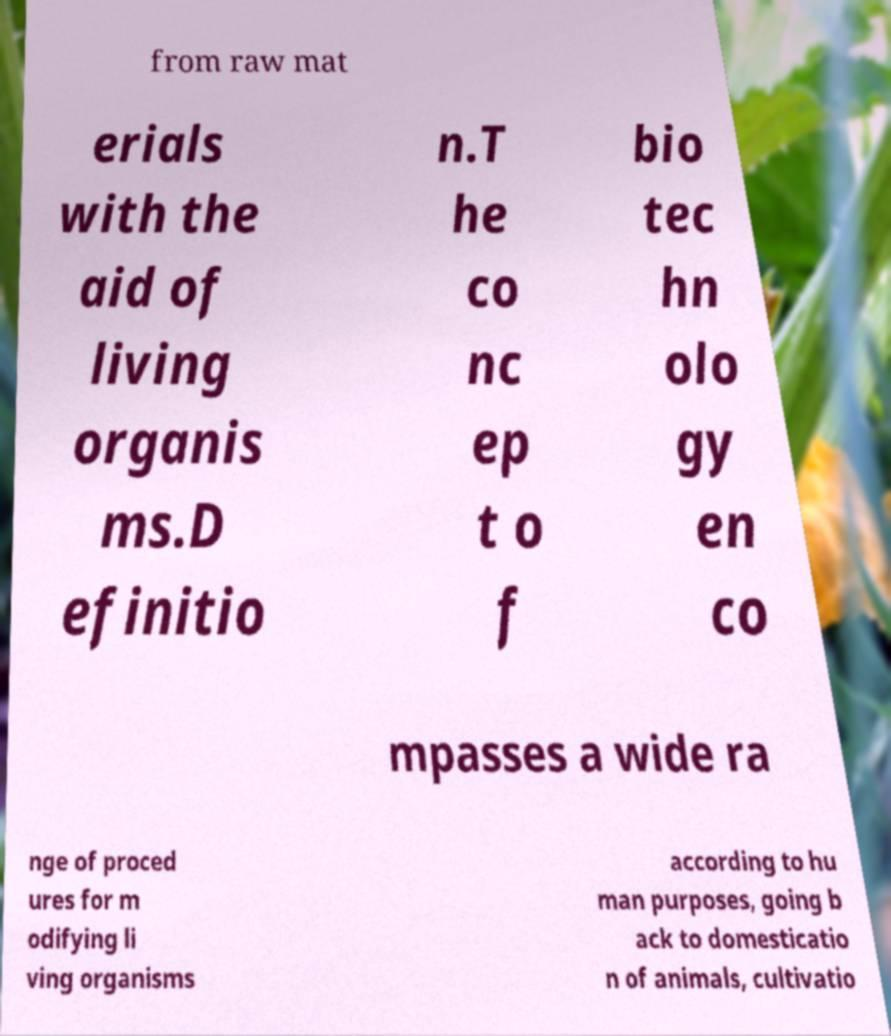Can you accurately transcribe the text from the provided image for me? from raw mat erials with the aid of living organis ms.D efinitio n.T he co nc ep t o f bio tec hn olo gy en co mpasses a wide ra nge of proced ures for m odifying li ving organisms according to hu man purposes, going b ack to domesticatio n of animals, cultivatio 